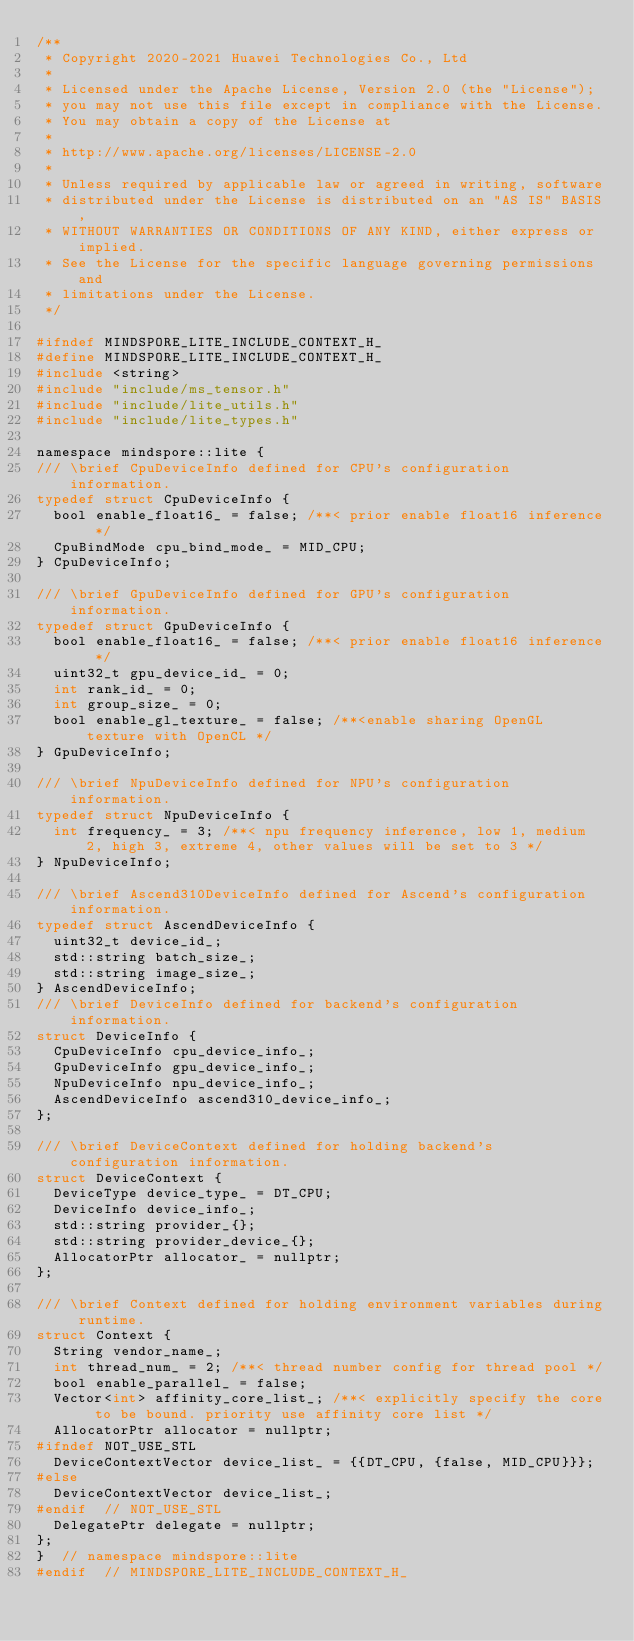<code> <loc_0><loc_0><loc_500><loc_500><_C_>/**
 * Copyright 2020-2021 Huawei Technologies Co., Ltd
 *
 * Licensed under the Apache License, Version 2.0 (the "License");
 * you may not use this file except in compliance with the License.
 * You may obtain a copy of the License at
 *
 * http://www.apache.org/licenses/LICENSE-2.0
 *
 * Unless required by applicable law or agreed in writing, software
 * distributed under the License is distributed on an "AS IS" BASIS,
 * WITHOUT WARRANTIES OR CONDITIONS OF ANY KIND, either express or implied.
 * See the License for the specific language governing permissions and
 * limitations under the License.
 */

#ifndef MINDSPORE_LITE_INCLUDE_CONTEXT_H_
#define MINDSPORE_LITE_INCLUDE_CONTEXT_H_
#include <string>
#include "include/ms_tensor.h"
#include "include/lite_utils.h"
#include "include/lite_types.h"

namespace mindspore::lite {
/// \brief CpuDeviceInfo defined for CPU's configuration information.
typedef struct CpuDeviceInfo {
  bool enable_float16_ = false; /**< prior enable float16 inference */
  CpuBindMode cpu_bind_mode_ = MID_CPU;
} CpuDeviceInfo;

/// \brief GpuDeviceInfo defined for GPU's configuration information.
typedef struct GpuDeviceInfo {
  bool enable_float16_ = false; /**< prior enable float16 inference */
  uint32_t gpu_device_id_ = 0;
  int rank_id_ = 0;
  int group_size_ = 0;
  bool enable_gl_texture_ = false; /**<enable sharing OpenGL texture with OpenCL */
} GpuDeviceInfo;

/// \brief NpuDeviceInfo defined for NPU's configuration information.
typedef struct NpuDeviceInfo {
  int frequency_ = 3; /**< npu frequency inference, low 1, medium 2, high 3, extreme 4, other values will be set to 3 */
} NpuDeviceInfo;

/// \brief Ascend310DeviceInfo defined for Ascend's configuration information.
typedef struct AscendDeviceInfo {
  uint32_t device_id_;
  std::string batch_size_;
  std::string image_size_;
} AscendDeviceInfo;
/// \brief DeviceInfo defined for backend's configuration information.
struct DeviceInfo {
  CpuDeviceInfo cpu_device_info_;
  GpuDeviceInfo gpu_device_info_;
  NpuDeviceInfo npu_device_info_;
  AscendDeviceInfo ascend310_device_info_;
};

/// \brief DeviceContext defined for holding backend's configuration information.
struct DeviceContext {
  DeviceType device_type_ = DT_CPU;
  DeviceInfo device_info_;
  std::string provider_{};
  std::string provider_device_{};
  AllocatorPtr allocator_ = nullptr;
};

/// \brief Context defined for holding environment variables during runtime.
struct Context {
  String vendor_name_;
  int thread_num_ = 2; /**< thread number config for thread pool */
  bool enable_parallel_ = false;
  Vector<int> affinity_core_list_; /**< explicitly specify the core to be bound. priority use affinity core list */
  AllocatorPtr allocator = nullptr;
#ifndef NOT_USE_STL
  DeviceContextVector device_list_ = {{DT_CPU, {false, MID_CPU}}};
#else
  DeviceContextVector device_list_;
#endif  // NOT_USE_STL
  DelegatePtr delegate = nullptr;
};
}  // namespace mindspore::lite
#endif  // MINDSPORE_LITE_INCLUDE_CONTEXT_H_
</code> 